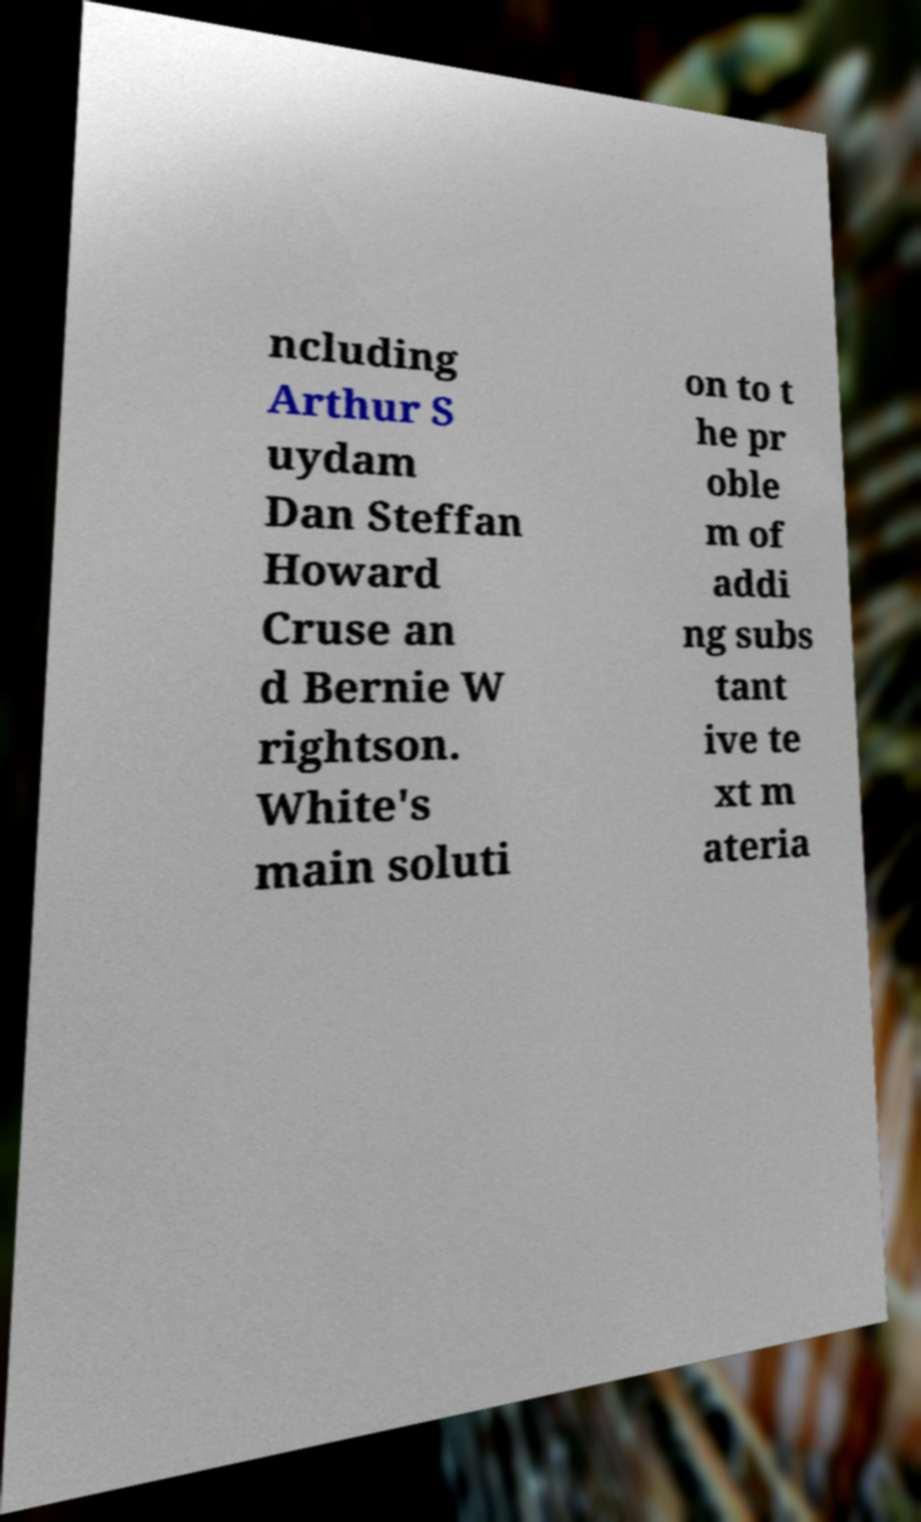Can you read and provide the text displayed in the image?This photo seems to have some interesting text. Can you extract and type it out for me? ncluding Arthur S uydam Dan Steffan Howard Cruse an d Bernie W rightson. White's main soluti on to t he pr oble m of addi ng subs tant ive te xt m ateria 